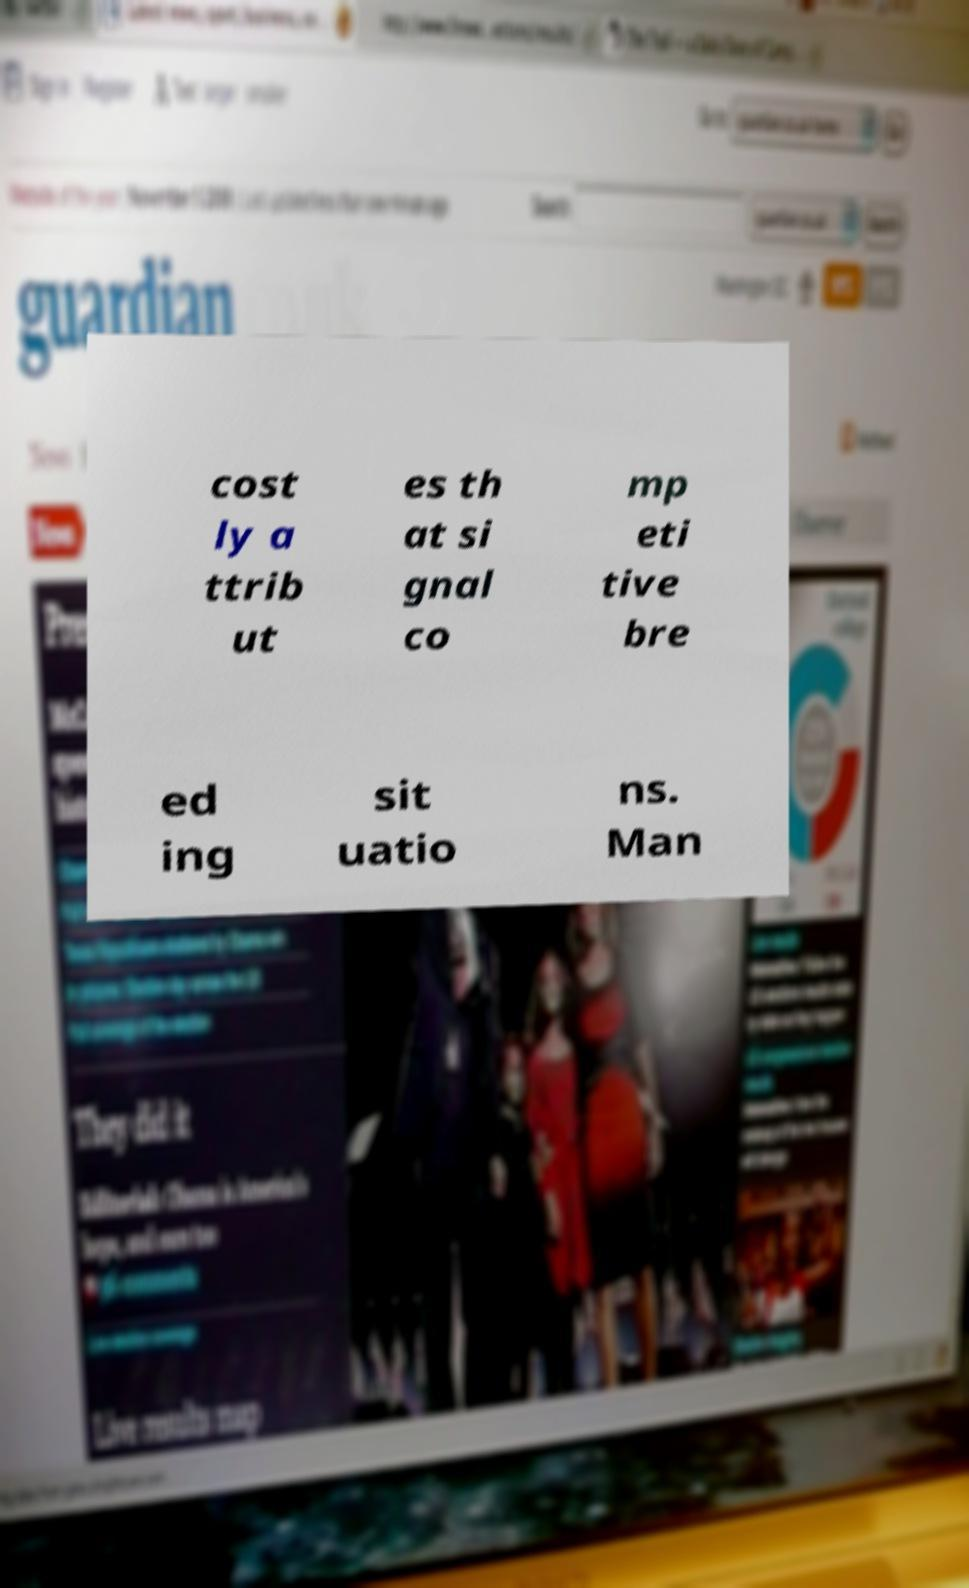Please identify and transcribe the text found in this image. cost ly a ttrib ut es th at si gnal co mp eti tive bre ed ing sit uatio ns. Man 